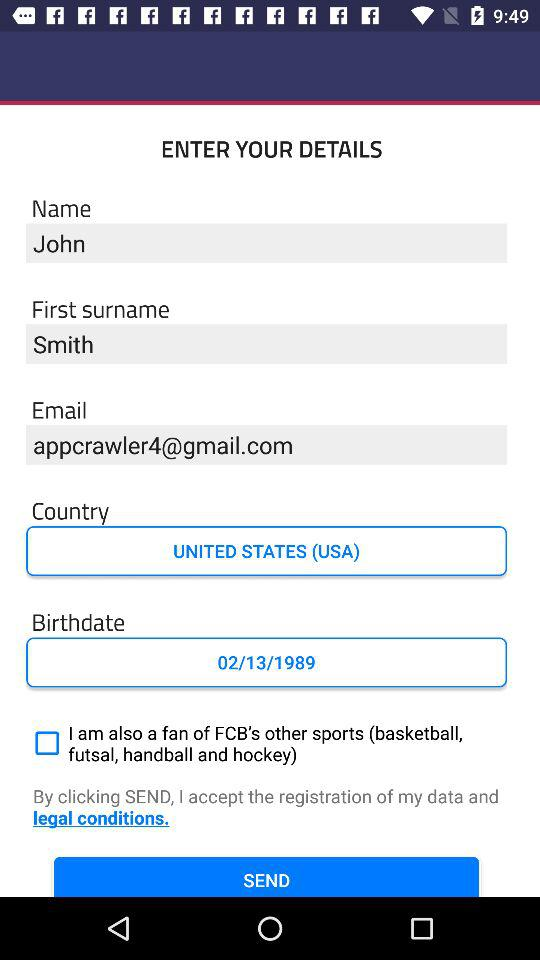What is the birthdate? The birthdate is February 13, 1989. 